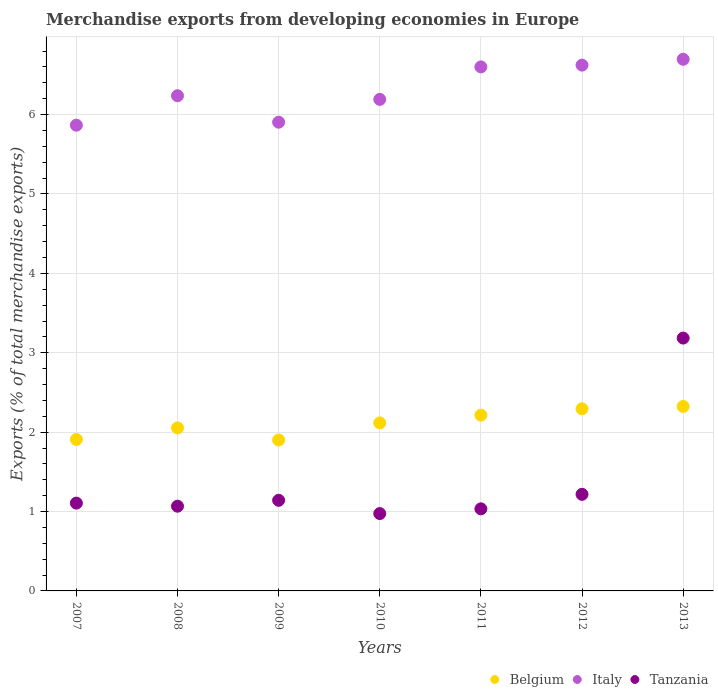Is the number of dotlines equal to the number of legend labels?
Your answer should be compact. Yes. What is the percentage of total merchandise exports in Italy in 2012?
Your response must be concise. 6.62. Across all years, what is the maximum percentage of total merchandise exports in Italy?
Make the answer very short. 6.7. Across all years, what is the minimum percentage of total merchandise exports in Tanzania?
Offer a very short reply. 0.97. What is the total percentage of total merchandise exports in Belgium in the graph?
Your answer should be compact. 14.81. What is the difference between the percentage of total merchandise exports in Tanzania in 2007 and that in 2008?
Your answer should be very brief. 0.04. What is the difference between the percentage of total merchandise exports in Tanzania in 2011 and the percentage of total merchandise exports in Italy in 2010?
Ensure brevity in your answer.  -5.16. What is the average percentage of total merchandise exports in Italy per year?
Give a very brief answer. 6.3. In the year 2009, what is the difference between the percentage of total merchandise exports in Italy and percentage of total merchandise exports in Tanzania?
Provide a succinct answer. 4.76. In how many years, is the percentage of total merchandise exports in Belgium greater than 0.4 %?
Your answer should be compact. 7. What is the ratio of the percentage of total merchandise exports in Italy in 2007 to that in 2011?
Ensure brevity in your answer.  0.89. Is the difference between the percentage of total merchandise exports in Italy in 2009 and 2011 greater than the difference between the percentage of total merchandise exports in Tanzania in 2009 and 2011?
Your response must be concise. No. What is the difference between the highest and the second highest percentage of total merchandise exports in Belgium?
Your answer should be very brief. 0.03. What is the difference between the highest and the lowest percentage of total merchandise exports in Italy?
Offer a terse response. 0.83. Is the sum of the percentage of total merchandise exports in Belgium in 2007 and 2013 greater than the maximum percentage of total merchandise exports in Tanzania across all years?
Make the answer very short. Yes. Is the percentage of total merchandise exports in Belgium strictly greater than the percentage of total merchandise exports in Italy over the years?
Provide a short and direct response. No. Is the percentage of total merchandise exports in Tanzania strictly less than the percentage of total merchandise exports in Belgium over the years?
Offer a very short reply. No. What is the difference between two consecutive major ticks on the Y-axis?
Make the answer very short. 1. Does the graph contain any zero values?
Give a very brief answer. No. Does the graph contain grids?
Provide a succinct answer. Yes. How many legend labels are there?
Your answer should be very brief. 3. How are the legend labels stacked?
Make the answer very short. Horizontal. What is the title of the graph?
Offer a terse response. Merchandise exports from developing economies in Europe. What is the label or title of the Y-axis?
Offer a terse response. Exports (% of total merchandise exports). What is the Exports (% of total merchandise exports) in Belgium in 2007?
Offer a terse response. 1.91. What is the Exports (% of total merchandise exports) of Italy in 2007?
Your answer should be very brief. 5.87. What is the Exports (% of total merchandise exports) of Tanzania in 2007?
Your answer should be compact. 1.11. What is the Exports (% of total merchandise exports) of Belgium in 2008?
Your answer should be compact. 2.05. What is the Exports (% of total merchandise exports) in Italy in 2008?
Offer a very short reply. 6.24. What is the Exports (% of total merchandise exports) in Tanzania in 2008?
Offer a terse response. 1.07. What is the Exports (% of total merchandise exports) in Belgium in 2009?
Your response must be concise. 1.9. What is the Exports (% of total merchandise exports) of Italy in 2009?
Provide a succinct answer. 5.9. What is the Exports (% of total merchandise exports) in Tanzania in 2009?
Offer a terse response. 1.14. What is the Exports (% of total merchandise exports) of Belgium in 2010?
Provide a short and direct response. 2.12. What is the Exports (% of total merchandise exports) of Italy in 2010?
Provide a short and direct response. 6.19. What is the Exports (% of total merchandise exports) in Tanzania in 2010?
Provide a short and direct response. 0.97. What is the Exports (% of total merchandise exports) of Belgium in 2011?
Keep it short and to the point. 2.21. What is the Exports (% of total merchandise exports) in Italy in 2011?
Keep it short and to the point. 6.6. What is the Exports (% of total merchandise exports) of Tanzania in 2011?
Your answer should be very brief. 1.03. What is the Exports (% of total merchandise exports) in Belgium in 2012?
Provide a succinct answer. 2.29. What is the Exports (% of total merchandise exports) in Italy in 2012?
Provide a succinct answer. 6.62. What is the Exports (% of total merchandise exports) of Tanzania in 2012?
Offer a terse response. 1.22. What is the Exports (% of total merchandise exports) of Belgium in 2013?
Your answer should be very brief. 2.32. What is the Exports (% of total merchandise exports) in Italy in 2013?
Your answer should be compact. 6.7. What is the Exports (% of total merchandise exports) in Tanzania in 2013?
Ensure brevity in your answer.  3.19. Across all years, what is the maximum Exports (% of total merchandise exports) of Belgium?
Keep it short and to the point. 2.32. Across all years, what is the maximum Exports (% of total merchandise exports) in Italy?
Your response must be concise. 6.7. Across all years, what is the maximum Exports (% of total merchandise exports) in Tanzania?
Keep it short and to the point. 3.19. Across all years, what is the minimum Exports (% of total merchandise exports) of Belgium?
Ensure brevity in your answer.  1.9. Across all years, what is the minimum Exports (% of total merchandise exports) in Italy?
Offer a terse response. 5.87. Across all years, what is the minimum Exports (% of total merchandise exports) in Tanzania?
Provide a succinct answer. 0.97. What is the total Exports (% of total merchandise exports) of Belgium in the graph?
Provide a succinct answer. 14.81. What is the total Exports (% of total merchandise exports) in Italy in the graph?
Provide a short and direct response. 44.12. What is the total Exports (% of total merchandise exports) of Tanzania in the graph?
Your answer should be compact. 9.73. What is the difference between the Exports (% of total merchandise exports) in Belgium in 2007 and that in 2008?
Your answer should be very brief. -0.15. What is the difference between the Exports (% of total merchandise exports) of Italy in 2007 and that in 2008?
Keep it short and to the point. -0.37. What is the difference between the Exports (% of total merchandise exports) of Tanzania in 2007 and that in 2008?
Make the answer very short. 0.04. What is the difference between the Exports (% of total merchandise exports) of Belgium in 2007 and that in 2009?
Keep it short and to the point. 0.01. What is the difference between the Exports (% of total merchandise exports) of Italy in 2007 and that in 2009?
Make the answer very short. -0.04. What is the difference between the Exports (% of total merchandise exports) in Tanzania in 2007 and that in 2009?
Ensure brevity in your answer.  -0.04. What is the difference between the Exports (% of total merchandise exports) in Belgium in 2007 and that in 2010?
Your answer should be very brief. -0.21. What is the difference between the Exports (% of total merchandise exports) in Italy in 2007 and that in 2010?
Provide a succinct answer. -0.33. What is the difference between the Exports (% of total merchandise exports) in Tanzania in 2007 and that in 2010?
Keep it short and to the point. 0.13. What is the difference between the Exports (% of total merchandise exports) in Belgium in 2007 and that in 2011?
Keep it short and to the point. -0.31. What is the difference between the Exports (% of total merchandise exports) of Italy in 2007 and that in 2011?
Offer a terse response. -0.73. What is the difference between the Exports (% of total merchandise exports) in Tanzania in 2007 and that in 2011?
Your answer should be very brief. 0.07. What is the difference between the Exports (% of total merchandise exports) of Belgium in 2007 and that in 2012?
Give a very brief answer. -0.39. What is the difference between the Exports (% of total merchandise exports) in Italy in 2007 and that in 2012?
Offer a very short reply. -0.76. What is the difference between the Exports (% of total merchandise exports) in Tanzania in 2007 and that in 2012?
Provide a short and direct response. -0.11. What is the difference between the Exports (% of total merchandise exports) of Belgium in 2007 and that in 2013?
Ensure brevity in your answer.  -0.42. What is the difference between the Exports (% of total merchandise exports) in Italy in 2007 and that in 2013?
Your answer should be compact. -0.83. What is the difference between the Exports (% of total merchandise exports) in Tanzania in 2007 and that in 2013?
Offer a very short reply. -2.08. What is the difference between the Exports (% of total merchandise exports) in Belgium in 2008 and that in 2009?
Offer a very short reply. 0.15. What is the difference between the Exports (% of total merchandise exports) in Italy in 2008 and that in 2009?
Ensure brevity in your answer.  0.33. What is the difference between the Exports (% of total merchandise exports) of Tanzania in 2008 and that in 2009?
Make the answer very short. -0.07. What is the difference between the Exports (% of total merchandise exports) of Belgium in 2008 and that in 2010?
Make the answer very short. -0.06. What is the difference between the Exports (% of total merchandise exports) of Italy in 2008 and that in 2010?
Provide a succinct answer. 0.05. What is the difference between the Exports (% of total merchandise exports) of Tanzania in 2008 and that in 2010?
Offer a terse response. 0.09. What is the difference between the Exports (% of total merchandise exports) of Belgium in 2008 and that in 2011?
Give a very brief answer. -0.16. What is the difference between the Exports (% of total merchandise exports) in Italy in 2008 and that in 2011?
Make the answer very short. -0.36. What is the difference between the Exports (% of total merchandise exports) of Tanzania in 2008 and that in 2011?
Your answer should be very brief. 0.03. What is the difference between the Exports (% of total merchandise exports) in Belgium in 2008 and that in 2012?
Keep it short and to the point. -0.24. What is the difference between the Exports (% of total merchandise exports) in Italy in 2008 and that in 2012?
Ensure brevity in your answer.  -0.39. What is the difference between the Exports (% of total merchandise exports) in Tanzania in 2008 and that in 2012?
Your answer should be compact. -0.15. What is the difference between the Exports (% of total merchandise exports) of Belgium in 2008 and that in 2013?
Your answer should be very brief. -0.27. What is the difference between the Exports (% of total merchandise exports) of Italy in 2008 and that in 2013?
Provide a short and direct response. -0.46. What is the difference between the Exports (% of total merchandise exports) in Tanzania in 2008 and that in 2013?
Offer a very short reply. -2.12. What is the difference between the Exports (% of total merchandise exports) of Belgium in 2009 and that in 2010?
Ensure brevity in your answer.  -0.21. What is the difference between the Exports (% of total merchandise exports) in Italy in 2009 and that in 2010?
Offer a terse response. -0.29. What is the difference between the Exports (% of total merchandise exports) of Tanzania in 2009 and that in 2010?
Keep it short and to the point. 0.17. What is the difference between the Exports (% of total merchandise exports) of Belgium in 2009 and that in 2011?
Your answer should be compact. -0.31. What is the difference between the Exports (% of total merchandise exports) in Italy in 2009 and that in 2011?
Keep it short and to the point. -0.7. What is the difference between the Exports (% of total merchandise exports) of Tanzania in 2009 and that in 2011?
Your answer should be very brief. 0.11. What is the difference between the Exports (% of total merchandise exports) of Belgium in 2009 and that in 2012?
Ensure brevity in your answer.  -0.39. What is the difference between the Exports (% of total merchandise exports) of Italy in 2009 and that in 2012?
Offer a terse response. -0.72. What is the difference between the Exports (% of total merchandise exports) in Tanzania in 2009 and that in 2012?
Your answer should be very brief. -0.08. What is the difference between the Exports (% of total merchandise exports) of Belgium in 2009 and that in 2013?
Offer a terse response. -0.42. What is the difference between the Exports (% of total merchandise exports) in Italy in 2009 and that in 2013?
Your response must be concise. -0.79. What is the difference between the Exports (% of total merchandise exports) in Tanzania in 2009 and that in 2013?
Provide a succinct answer. -2.04. What is the difference between the Exports (% of total merchandise exports) of Belgium in 2010 and that in 2011?
Ensure brevity in your answer.  -0.1. What is the difference between the Exports (% of total merchandise exports) in Italy in 2010 and that in 2011?
Give a very brief answer. -0.41. What is the difference between the Exports (% of total merchandise exports) of Tanzania in 2010 and that in 2011?
Your response must be concise. -0.06. What is the difference between the Exports (% of total merchandise exports) of Belgium in 2010 and that in 2012?
Your response must be concise. -0.18. What is the difference between the Exports (% of total merchandise exports) in Italy in 2010 and that in 2012?
Provide a short and direct response. -0.43. What is the difference between the Exports (% of total merchandise exports) in Tanzania in 2010 and that in 2012?
Give a very brief answer. -0.24. What is the difference between the Exports (% of total merchandise exports) in Belgium in 2010 and that in 2013?
Make the answer very short. -0.21. What is the difference between the Exports (% of total merchandise exports) in Italy in 2010 and that in 2013?
Keep it short and to the point. -0.51. What is the difference between the Exports (% of total merchandise exports) of Tanzania in 2010 and that in 2013?
Offer a very short reply. -2.21. What is the difference between the Exports (% of total merchandise exports) of Belgium in 2011 and that in 2012?
Your answer should be very brief. -0.08. What is the difference between the Exports (% of total merchandise exports) in Italy in 2011 and that in 2012?
Your answer should be compact. -0.02. What is the difference between the Exports (% of total merchandise exports) of Tanzania in 2011 and that in 2012?
Offer a very short reply. -0.18. What is the difference between the Exports (% of total merchandise exports) in Belgium in 2011 and that in 2013?
Offer a terse response. -0.11. What is the difference between the Exports (% of total merchandise exports) of Italy in 2011 and that in 2013?
Ensure brevity in your answer.  -0.1. What is the difference between the Exports (% of total merchandise exports) of Tanzania in 2011 and that in 2013?
Offer a very short reply. -2.15. What is the difference between the Exports (% of total merchandise exports) of Belgium in 2012 and that in 2013?
Your answer should be compact. -0.03. What is the difference between the Exports (% of total merchandise exports) of Italy in 2012 and that in 2013?
Your answer should be very brief. -0.07. What is the difference between the Exports (% of total merchandise exports) of Tanzania in 2012 and that in 2013?
Offer a terse response. -1.97. What is the difference between the Exports (% of total merchandise exports) of Belgium in 2007 and the Exports (% of total merchandise exports) of Italy in 2008?
Offer a terse response. -4.33. What is the difference between the Exports (% of total merchandise exports) in Belgium in 2007 and the Exports (% of total merchandise exports) in Tanzania in 2008?
Provide a short and direct response. 0.84. What is the difference between the Exports (% of total merchandise exports) in Italy in 2007 and the Exports (% of total merchandise exports) in Tanzania in 2008?
Your response must be concise. 4.8. What is the difference between the Exports (% of total merchandise exports) in Belgium in 2007 and the Exports (% of total merchandise exports) in Italy in 2009?
Offer a very short reply. -4. What is the difference between the Exports (% of total merchandise exports) of Belgium in 2007 and the Exports (% of total merchandise exports) of Tanzania in 2009?
Offer a terse response. 0.77. What is the difference between the Exports (% of total merchandise exports) in Italy in 2007 and the Exports (% of total merchandise exports) in Tanzania in 2009?
Ensure brevity in your answer.  4.73. What is the difference between the Exports (% of total merchandise exports) of Belgium in 2007 and the Exports (% of total merchandise exports) of Italy in 2010?
Make the answer very short. -4.28. What is the difference between the Exports (% of total merchandise exports) in Belgium in 2007 and the Exports (% of total merchandise exports) in Tanzania in 2010?
Your answer should be compact. 0.93. What is the difference between the Exports (% of total merchandise exports) in Italy in 2007 and the Exports (% of total merchandise exports) in Tanzania in 2010?
Keep it short and to the point. 4.89. What is the difference between the Exports (% of total merchandise exports) of Belgium in 2007 and the Exports (% of total merchandise exports) of Italy in 2011?
Give a very brief answer. -4.69. What is the difference between the Exports (% of total merchandise exports) in Belgium in 2007 and the Exports (% of total merchandise exports) in Tanzania in 2011?
Ensure brevity in your answer.  0.87. What is the difference between the Exports (% of total merchandise exports) in Italy in 2007 and the Exports (% of total merchandise exports) in Tanzania in 2011?
Provide a succinct answer. 4.83. What is the difference between the Exports (% of total merchandise exports) in Belgium in 2007 and the Exports (% of total merchandise exports) in Italy in 2012?
Provide a short and direct response. -4.72. What is the difference between the Exports (% of total merchandise exports) of Belgium in 2007 and the Exports (% of total merchandise exports) of Tanzania in 2012?
Keep it short and to the point. 0.69. What is the difference between the Exports (% of total merchandise exports) in Italy in 2007 and the Exports (% of total merchandise exports) in Tanzania in 2012?
Keep it short and to the point. 4.65. What is the difference between the Exports (% of total merchandise exports) of Belgium in 2007 and the Exports (% of total merchandise exports) of Italy in 2013?
Offer a very short reply. -4.79. What is the difference between the Exports (% of total merchandise exports) of Belgium in 2007 and the Exports (% of total merchandise exports) of Tanzania in 2013?
Your answer should be very brief. -1.28. What is the difference between the Exports (% of total merchandise exports) in Italy in 2007 and the Exports (% of total merchandise exports) in Tanzania in 2013?
Give a very brief answer. 2.68. What is the difference between the Exports (% of total merchandise exports) of Belgium in 2008 and the Exports (% of total merchandise exports) of Italy in 2009?
Provide a short and direct response. -3.85. What is the difference between the Exports (% of total merchandise exports) in Belgium in 2008 and the Exports (% of total merchandise exports) in Tanzania in 2009?
Make the answer very short. 0.91. What is the difference between the Exports (% of total merchandise exports) of Italy in 2008 and the Exports (% of total merchandise exports) of Tanzania in 2009?
Keep it short and to the point. 5.1. What is the difference between the Exports (% of total merchandise exports) in Belgium in 2008 and the Exports (% of total merchandise exports) in Italy in 2010?
Your response must be concise. -4.14. What is the difference between the Exports (% of total merchandise exports) of Belgium in 2008 and the Exports (% of total merchandise exports) of Tanzania in 2010?
Offer a terse response. 1.08. What is the difference between the Exports (% of total merchandise exports) in Italy in 2008 and the Exports (% of total merchandise exports) in Tanzania in 2010?
Offer a terse response. 5.26. What is the difference between the Exports (% of total merchandise exports) in Belgium in 2008 and the Exports (% of total merchandise exports) in Italy in 2011?
Offer a very short reply. -4.55. What is the difference between the Exports (% of total merchandise exports) of Belgium in 2008 and the Exports (% of total merchandise exports) of Tanzania in 2011?
Provide a short and direct response. 1.02. What is the difference between the Exports (% of total merchandise exports) of Italy in 2008 and the Exports (% of total merchandise exports) of Tanzania in 2011?
Keep it short and to the point. 5.2. What is the difference between the Exports (% of total merchandise exports) in Belgium in 2008 and the Exports (% of total merchandise exports) in Italy in 2012?
Give a very brief answer. -4.57. What is the difference between the Exports (% of total merchandise exports) of Belgium in 2008 and the Exports (% of total merchandise exports) of Tanzania in 2012?
Keep it short and to the point. 0.84. What is the difference between the Exports (% of total merchandise exports) in Italy in 2008 and the Exports (% of total merchandise exports) in Tanzania in 2012?
Make the answer very short. 5.02. What is the difference between the Exports (% of total merchandise exports) in Belgium in 2008 and the Exports (% of total merchandise exports) in Italy in 2013?
Provide a succinct answer. -4.64. What is the difference between the Exports (% of total merchandise exports) of Belgium in 2008 and the Exports (% of total merchandise exports) of Tanzania in 2013?
Keep it short and to the point. -1.13. What is the difference between the Exports (% of total merchandise exports) in Italy in 2008 and the Exports (% of total merchandise exports) in Tanzania in 2013?
Your answer should be very brief. 3.05. What is the difference between the Exports (% of total merchandise exports) of Belgium in 2009 and the Exports (% of total merchandise exports) of Italy in 2010?
Keep it short and to the point. -4.29. What is the difference between the Exports (% of total merchandise exports) of Belgium in 2009 and the Exports (% of total merchandise exports) of Tanzania in 2010?
Provide a short and direct response. 0.93. What is the difference between the Exports (% of total merchandise exports) of Italy in 2009 and the Exports (% of total merchandise exports) of Tanzania in 2010?
Provide a short and direct response. 4.93. What is the difference between the Exports (% of total merchandise exports) of Belgium in 2009 and the Exports (% of total merchandise exports) of Italy in 2011?
Keep it short and to the point. -4.7. What is the difference between the Exports (% of total merchandise exports) in Belgium in 2009 and the Exports (% of total merchandise exports) in Tanzania in 2011?
Your response must be concise. 0.87. What is the difference between the Exports (% of total merchandise exports) in Italy in 2009 and the Exports (% of total merchandise exports) in Tanzania in 2011?
Provide a short and direct response. 4.87. What is the difference between the Exports (% of total merchandise exports) in Belgium in 2009 and the Exports (% of total merchandise exports) in Italy in 2012?
Your response must be concise. -4.72. What is the difference between the Exports (% of total merchandise exports) of Belgium in 2009 and the Exports (% of total merchandise exports) of Tanzania in 2012?
Your answer should be very brief. 0.68. What is the difference between the Exports (% of total merchandise exports) in Italy in 2009 and the Exports (% of total merchandise exports) in Tanzania in 2012?
Offer a very short reply. 4.69. What is the difference between the Exports (% of total merchandise exports) of Belgium in 2009 and the Exports (% of total merchandise exports) of Italy in 2013?
Keep it short and to the point. -4.8. What is the difference between the Exports (% of total merchandise exports) of Belgium in 2009 and the Exports (% of total merchandise exports) of Tanzania in 2013?
Keep it short and to the point. -1.28. What is the difference between the Exports (% of total merchandise exports) in Italy in 2009 and the Exports (% of total merchandise exports) in Tanzania in 2013?
Provide a succinct answer. 2.72. What is the difference between the Exports (% of total merchandise exports) in Belgium in 2010 and the Exports (% of total merchandise exports) in Italy in 2011?
Your answer should be compact. -4.48. What is the difference between the Exports (% of total merchandise exports) of Belgium in 2010 and the Exports (% of total merchandise exports) of Tanzania in 2011?
Make the answer very short. 1.08. What is the difference between the Exports (% of total merchandise exports) in Italy in 2010 and the Exports (% of total merchandise exports) in Tanzania in 2011?
Offer a very short reply. 5.16. What is the difference between the Exports (% of total merchandise exports) of Belgium in 2010 and the Exports (% of total merchandise exports) of Italy in 2012?
Give a very brief answer. -4.51. What is the difference between the Exports (% of total merchandise exports) of Belgium in 2010 and the Exports (% of total merchandise exports) of Tanzania in 2012?
Your answer should be compact. 0.9. What is the difference between the Exports (% of total merchandise exports) of Italy in 2010 and the Exports (% of total merchandise exports) of Tanzania in 2012?
Ensure brevity in your answer.  4.97. What is the difference between the Exports (% of total merchandise exports) in Belgium in 2010 and the Exports (% of total merchandise exports) in Italy in 2013?
Offer a very short reply. -4.58. What is the difference between the Exports (% of total merchandise exports) in Belgium in 2010 and the Exports (% of total merchandise exports) in Tanzania in 2013?
Provide a succinct answer. -1.07. What is the difference between the Exports (% of total merchandise exports) in Italy in 2010 and the Exports (% of total merchandise exports) in Tanzania in 2013?
Your answer should be compact. 3.01. What is the difference between the Exports (% of total merchandise exports) in Belgium in 2011 and the Exports (% of total merchandise exports) in Italy in 2012?
Keep it short and to the point. -4.41. What is the difference between the Exports (% of total merchandise exports) in Belgium in 2011 and the Exports (% of total merchandise exports) in Tanzania in 2012?
Provide a succinct answer. 1. What is the difference between the Exports (% of total merchandise exports) in Italy in 2011 and the Exports (% of total merchandise exports) in Tanzania in 2012?
Keep it short and to the point. 5.38. What is the difference between the Exports (% of total merchandise exports) in Belgium in 2011 and the Exports (% of total merchandise exports) in Italy in 2013?
Your answer should be compact. -4.48. What is the difference between the Exports (% of total merchandise exports) in Belgium in 2011 and the Exports (% of total merchandise exports) in Tanzania in 2013?
Offer a very short reply. -0.97. What is the difference between the Exports (% of total merchandise exports) of Italy in 2011 and the Exports (% of total merchandise exports) of Tanzania in 2013?
Offer a terse response. 3.42. What is the difference between the Exports (% of total merchandise exports) of Belgium in 2012 and the Exports (% of total merchandise exports) of Italy in 2013?
Your response must be concise. -4.4. What is the difference between the Exports (% of total merchandise exports) of Belgium in 2012 and the Exports (% of total merchandise exports) of Tanzania in 2013?
Give a very brief answer. -0.89. What is the difference between the Exports (% of total merchandise exports) of Italy in 2012 and the Exports (% of total merchandise exports) of Tanzania in 2013?
Give a very brief answer. 3.44. What is the average Exports (% of total merchandise exports) of Belgium per year?
Ensure brevity in your answer.  2.12. What is the average Exports (% of total merchandise exports) in Italy per year?
Your answer should be very brief. 6.3. What is the average Exports (% of total merchandise exports) of Tanzania per year?
Give a very brief answer. 1.39. In the year 2007, what is the difference between the Exports (% of total merchandise exports) in Belgium and Exports (% of total merchandise exports) in Italy?
Your answer should be compact. -3.96. In the year 2007, what is the difference between the Exports (% of total merchandise exports) of Belgium and Exports (% of total merchandise exports) of Tanzania?
Make the answer very short. 0.8. In the year 2007, what is the difference between the Exports (% of total merchandise exports) in Italy and Exports (% of total merchandise exports) in Tanzania?
Your response must be concise. 4.76. In the year 2008, what is the difference between the Exports (% of total merchandise exports) in Belgium and Exports (% of total merchandise exports) in Italy?
Give a very brief answer. -4.18. In the year 2008, what is the difference between the Exports (% of total merchandise exports) of Belgium and Exports (% of total merchandise exports) of Tanzania?
Make the answer very short. 0.99. In the year 2008, what is the difference between the Exports (% of total merchandise exports) in Italy and Exports (% of total merchandise exports) in Tanzania?
Keep it short and to the point. 5.17. In the year 2009, what is the difference between the Exports (% of total merchandise exports) of Belgium and Exports (% of total merchandise exports) of Italy?
Make the answer very short. -4. In the year 2009, what is the difference between the Exports (% of total merchandise exports) of Belgium and Exports (% of total merchandise exports) of Tanzania?
Make the answer very short. 0.76. In the year 2009, what is the difference between the Exports (% of total merchandise exports) of Italy and Exports (% of total merchandise exports) of Tanzania?
Provide a short and direct response. 4.76. In the year 2010, what is the difference between the Exports (% of total merchandise exports) of Belgium and Exports (% of total merchandise exports) of Italy?
Offer a very short reply. -4.08. In the year 2010, what is the difference between the Exports (% of total merchandise exports) in Belgium and Exports (% of total merchandise exports) in Tanzania?
Keep it short and to the point. 1.14. In the year 2010, what is the difference between the Exports (% of total merchandise exports) of Italy and Exports (% of total merchandise exports) of Tanzania?
Your answer should be very brief. 5.22. In the year 2011, what is the difference between the Exports (% of total merchandise exports) of Belgium and Exports (% of total merchandise exports) of Italy?
Offer a terse response. -4.39. In the year 2011, what is the difference between the Exports (% of total merchandise exports) in Belgium and Exports (% of total merchandise exports) in Tanzania?
Your answer should be very brief. 1.18. In the year 2011, what is the difference between the Exports (% of total merchandise exports) of Italy and Exports (% of total merchandise exports) of Tanzania?
Keep it short and to the point. 5.57. In the year 2012, what is the difference between the Exports (% of total merchandise exports) in Belgium and Exports (% of total merchandise exports) in Italy?
Offer a very short reply. -4.33. In the year 2012, what is the difference between the Exports (% of total merchandise exports) of Belgium and Exports (% of total merchandise exports) of Tanzania?
Provide a short and direct response. 1.08. In the year 2012, what is the difference between the Exports (% of total merchandise exports) in Italy and Exports (% of total merchandise exports) in Tanzania?
Provide a short and direct response. 5.41. In the year 2013, what is the difference between the Exports (% of total merchandise exports) in Belgium and Exports (% of total merchandise exports) in Italy?
Offer a very short reply. -4.37. In the year 2013, what is the difference between the Exports (% of total merchandise exports) in Belgium and Exports (% of total merchandise exports) in Tanzania?
Ensure brevity in your answer.  -0.86. In the year 2013, what is the difference between the Exports (% of total merchandise exports) in Italy and Exports (% of total merchandise exports) in Tanzania?
Provide a short and direct response. 3.51. What is the ratio of the Exports (% of total merchandise exports) of Belgium in 2007 to that in 2008?
Offer a very short reply. 0.93. What is the ratio of the Exports (% of total merchandise exports) of Italy in 2007 to that in 2008?
Your answer should be very brief. 0.94. What is the ratio of the Exports (% of total merchandise exports) of Tanzania in 2007 to that in 2008?
Your response must be concise. 1.04. What is the ratio of the Exports (% of total merchandise exports) of Belgium in 2007 to that in 2010?
Make the answer very short. 0.9. What is the ratio of the Exports (% of total merchandise exports) of Italy in 2007 to that in 2010?
Your answer should be compact. 0.95. What is the ratio of the Exports (% of total merchandise exports) of Tanzania in 2007 to that in 2010?
Give a very brief answer. 1.14. What is the ratio of the Exports (% of total merchandise exports) in Belgium in 2007 to that in 2011?
Ensure brevity in your answer.  0.86. What is the ratio of the Exports (% of total merchandise exports) in Italy in 2007 to that in 2011?
Provide a short and direct response. 0.89. What is the ratio of the Exports (% of total merchandise exports) in Tanzania in 2007 to that in 2011?
Keep it short and to the point. 1.07. What is the ratio of the Exports (% of total merchandise exports) in Belgium in 2007 to that in 2012?
Ensure brevity in your answer.  0.83. What is the ratio of the Exports (% of total merchandise exports) in Italy in 2007 to that in 2012?
Keep it short and to the point. 0.89. What is the ratio of the Exports (% of total merchandise exports) of Tanzania in 2007 to that in 2012?
Make the answer very short. 0.91. What is the ratio of the Exports (% of total merchandise exports) in Belgium in 2007 to that in 2013?
Offer a terse response. 0.82. What is the ratio of the Exports (% of total merchandise exports) of Italy in 2007 to that in 2013?
Provide a succinct answer. 0.88. What is the ratio of the Exports (% of total merchandise exports) of Tanzania in 2007 to that in 2013?
Give a very brief answer. 0.35. What is the ratio of the Exports (% of total merchandise exports) of Belgium in 2008 to that in 2009?
Your response must be concise. 1.08. What is the ratio of the Exports (% of total merchandise exports) in Italy in 2008 to that in 2009?
Your answer should be very brief. 1.06. What is the ratio of the Exports (% of total merchandise exports) in Tanzania in 2008 to that in 2009?
Your response must be concise. 0.93. What is the ratio of the Exports (% of total merchandise exports) in Belgium in 2008 to that in 2010?
Your response must be concise. 0.97. What is the ratio of the Exports (% of total merchandise exports) in Italy in 2008 to that in 2010?
Give a very brief answer. 1.01. What is the ratio of the Exports (% of total merchandise exports) in Tanzania in 2008 to that in 2010?
Offer a terse response. 1.1. What is the ratio of the Exports (% of total merchandise exports) of Belgium in 2008 to that in 2011?
Keep it short and to the point. 0.93. What is the ratio of the Exports (% of total merchandise exports) of Italy in 2008 to that in 2011?
Offer a very short reply. 0.94. What is the ratio of the Exports (% of total merchandise exports) of Tanzania in 2008 to that in 2011?
Your answer should be very brief. 1.03. What is the ratio of the Exports (% of total merchandise exports) of Belgium in 2008 to that in 2012?
Offer a very short reply. 0.9. What is the ratio of the Exports (% of total merchandise exports) of Italy in 2008 to that in 2012?
Give a very brief answer. 0.94. What is the ratio of the Exports (% of total merchandise exports) in Tanzania in 2008 to that in 2012?
Provide a short and direct response. 0.88. What is the ratio of the Exports (% of total merchandise exports) of Belgium in 2008 to that in 2013?
Offer a very short reply. 0.88. What is the ratio of the Exports (% of total merchandise exports) in Italy in 2008 to that in 2013?
Give a very brief answer. 0.93. What is the ratio of the Exports (% of total merchandise exports) in Tanzania in 2008 to that in 2013?
Keep it short and to the point. 0.34. What is the ratio of the Exports (% of total merchandise exports) in Belgium in 2009 to that in 2010?
Make the answer very short. 0.9. What is the ratio of the Exports (% of total merchandise exports) of Italy in 2009 to that in 2010?
Offer a very short reply. 0.95. What is the ratio of the Exports (% of total merchandise exports) of Tanzania in 2009 to that in 2010?
Your answer should be compact. 1.17. What is the ratio of the Exports (% of total merchandise exports) in Belgium in 2009 to that in 2011?
Offer a very short reply. 0.86. What is the ratio of the Exports (% of total merchandise exports) in Italy in 2009 to that in 2011?
Give a very brief answer. 0.89. What is the ratio of the Exports (% of total merchandise exports) in Tanzania in 2009 to that in 2011?
Your response must be concise. 1.1. What is the ratio of the Exports (% of total merchandise exports) in Belgium in 2009 to that in 2012?
Offer a terse response. 0.83. What is the ratio of the Exports (% of total merchandise exports) of Italy in 2009 to that in 2012?
Your answer should be very brief. 0.89. What is the ratio of the Exports (% of total merchandise exports) in Tanzania in 2009 to that in 2012?
Your answer should be compact. 0.94. What is the ratio of the Exports (% of total merchandise exports) in Belgium in 2009 to that in 2013?
Your answer should be compact. 0.82. What is the ratio of the Exports (% of total merchandise exports) of Italy in 2009 to that in 2013?
Ensure brevity in your answer.  0.88. What is the ratio of the Exports (% of total merchandise exports) of Tanzania in 2009 to that in 2013?
Your response must be concise. 0.36. What is the ratio of the Exports (% of total merchandise exports) of Belgium in 2010 to that in 2011?
Provide a short and direct response. 0.96. What is the ratio of the Exports (% of total merchandise exports) of Italy in 2010 to that in 2011?
Give a very brief answer. 0.94. What is the ratio of the Exports (% of total merchandise exports) of Tanzania in 2010 to that in 2011?
Your answer should be very brief. 0.94. What is the ratio of the Exports (% of total merchandise exports) of Belgium in 2010 to that in 2012?
Your answer should be compact. 0.92. What is the ratio of the Exports (% of total merchandise exports) of Italy in 2010 to that in 2012?
Your answer should be very brief. 0.93. What is the ratio of the Exports (% of total merchandise exports) in Tanzania in 2010 to that in 2012?
Offer a terse response. 0.8. What is the ratio of the Exports (% of total merchandise exports) in Belgium in 2010 to that in 2013?
Offer a terse response. 0.91. What is the ratio of the Exports (% of total merchandise exports) in Italy in 2010 to that in 2013?
Your answer should be compact. 0.92. What is the ratio of the Exports (% of total merchandise exports) of Tanzania in 2010 to that in 2013?
Make the answer very short. 0.31. What is the ratio of the Exports (% of total merchandise exports) of Belgium in 2011 to that in 2012?
Offer a very short reply. 0.97. What is the ratio of the Exports (% of total merchandise exports) of Tanzania in 2011 to that in 2012?
Ensure brevity in your answer.  0.85. What is the ratio of the Exports (% of total merchandise exports) in Belgium in 2011 to that in 2013?
Make the answer very short. 0.95. What is the ratio of the Exports (% of total merchandise exports) in Italy in 2011 to that in 2013?
Offer a very short reply. 0.99. What is the ratio of the Exports (% of total merchandise exports) of Tanzania in 2011 to that in 2013?
Make the answer very short. 0.32. What is the ratio of the Exports (% of total merchandise exports) of Belgium in 2012 to that in 2013?
Keep it short and to the point. 0.99. What is the ratio of the Exports (% of total merchandise exports) of Tanzania in 2012 to that in 2013?
Your answer should be compact. 0.38. What is the difference between the highest and the second highest Exports (% of total merchandise exports) in Belgium?
Make the answer very short. 0.03. What is the difference between the highest and the second highest Exports (% of total merchandise exports) of Italy?
Offer a very short reply. 0.07. What is the difference between the highest and the second highest Exports (% of total merchandise exports) in Tanzania?
Make the answer very short. 1.97. What is the difference between the highest and the lowest Exports (% of total merchandise exports) of Belgium?
Give a very brief answer. 0.42. What is the difference between the highest and the lowest Exports (% of total merchandise exports) of Italy?
Provide a short and direct response. 0.83. What is the difference between the highest and the lowest Exports (% of total merchandise exports) of Tanzania?
Provide a short and direct response. 2.21. 